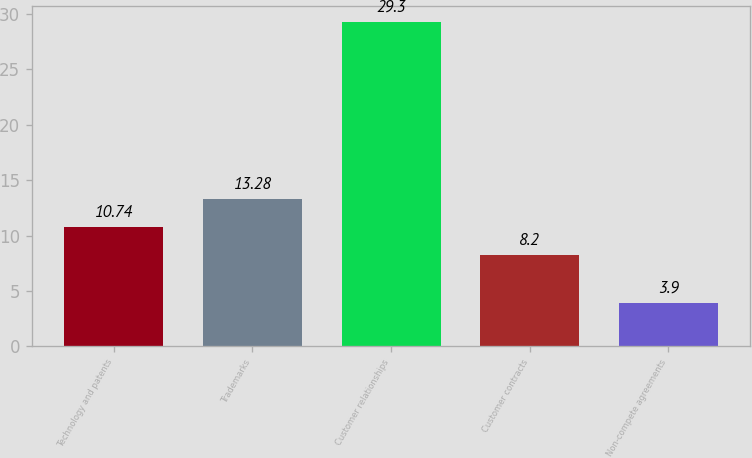<chart> <loc_0><loc_0><loc_500><loc_500><bar_chart><fcel>Technology and patents<fcel>Trademarks<fcel>Customer relationships<fcel>Customer contracts<fcel>Non-compete agreements<nl><fcel>10.74<fcel>13.28<fcel>29.3<fcel>8.2<fcel>3.9<nl></chart> 